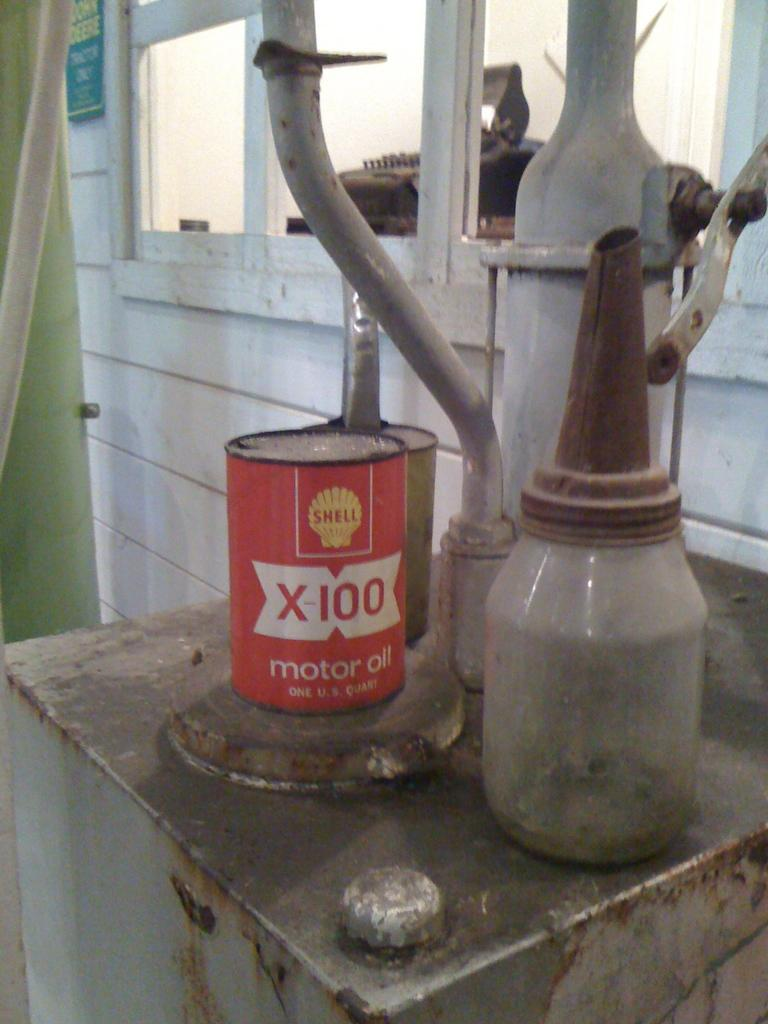<image>
Summarize the visual content of the image. A old can of shell motor oil sits on a metal box. 